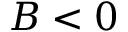<formula> <loc_0><loc_0><loc_500><loc_500>B < 0</formula> 